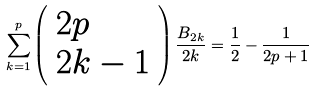Convert formula to latex. <formula><loc_0><loc_0><loc_500><loc_500>\sum _ { k = 1 } ^ { p } \left ( \begin{array} { l } { 2 p } \\ { 2 k - 1 } \end{array} \right ) \frac { B _ { 2 k } } { 2 k } = \frac { 1 } { 2 } - \frac { 1 } { 2 p + 1 }</formula> 